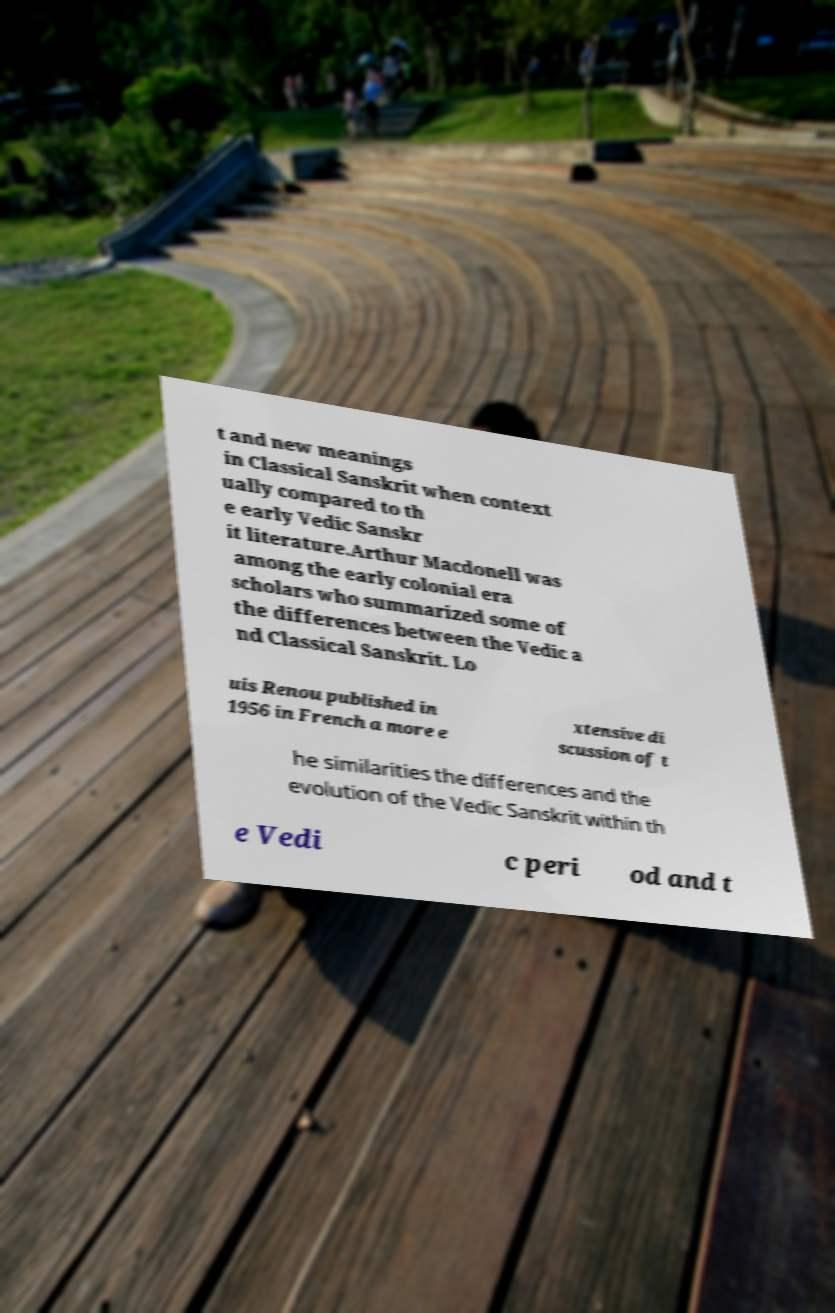Can you read and provide the text displayed in the image?This photo seems to have some interesting text. Can you extract and type it out for me? t and new meanings in Classical Sanskrit when context ually compared to th e early Vedic Sanskr it literature.Arthur Macdonell was among the early colonial era scholars who summarized some of the differences between the Vedic a nd Classical Sanskrit. Lo uis Renou published in 1956 in French a more e xtensive di scussion of t he similarities the differences and the evolution of the Vedic Sanskrit within th e Vedi c peri od and t 